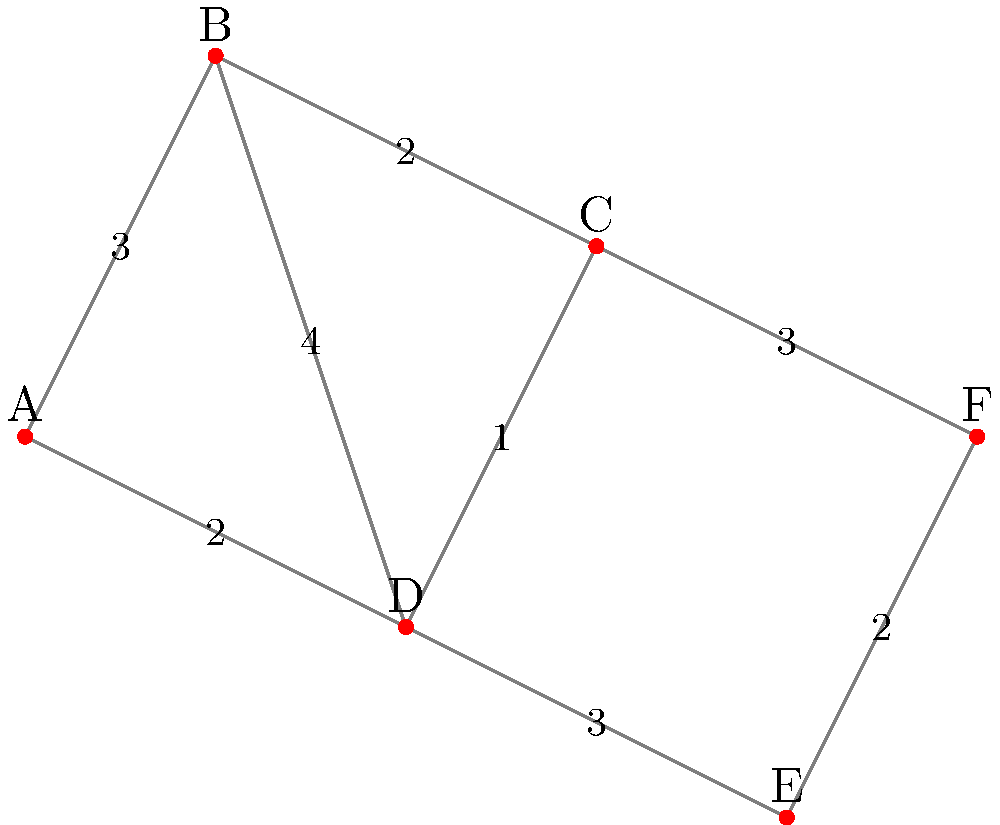In a multi-state consumer protection case involving an automotive manufacturer, you need to visit multiple legal jurisdictions represented by cities A through F. The numbers on the edges represent the travel time in hours between cities. What is the shortest path from city A to city F, and what is the total travel time? To solve this problem, we'll use Dijkstra's algorithm to find the shortest path from A to F:

1. Initialize:
   - Set distance to A as 0, all others as infinity
   - Set all nodes as unvisited
   - Set A as the current node

2. For the current node, consider all unvisited neighbors and calculate their tentative distances:
   - A to B: 3 hours
   - A to D: 2 hours

3. Mark A as visited. Set D as the current node (smallest tentative distance).

4. From D:
   - D to B: 2 + 4 = 6 hours (longer than direct A to B)
   - D to C: 2 + 1 = 3 hours
   - D to E: 2 + 3 = 5 hours

5. Mark D as visited. Set C as the current node.

6. From C:
   - C to B: 3 + 2 = 5 hours (shorter than direct A to B)
   - C to F: 3 + 3 = 6 hours

7. Mark C as visited. Set E as the current node.

8. From E:
   - E to F: 5 + 2 = 7 hours (shorter than via C)

9. Mark E as visited. Set B as the current node.

10. From B: No unvisited neighbors.

11. Mark B as visited. Set F as the current node.

The shortest path is A → D → E → F, with a total travel time of 7 hours.
Answer: A → D → E → F, 7 hours 